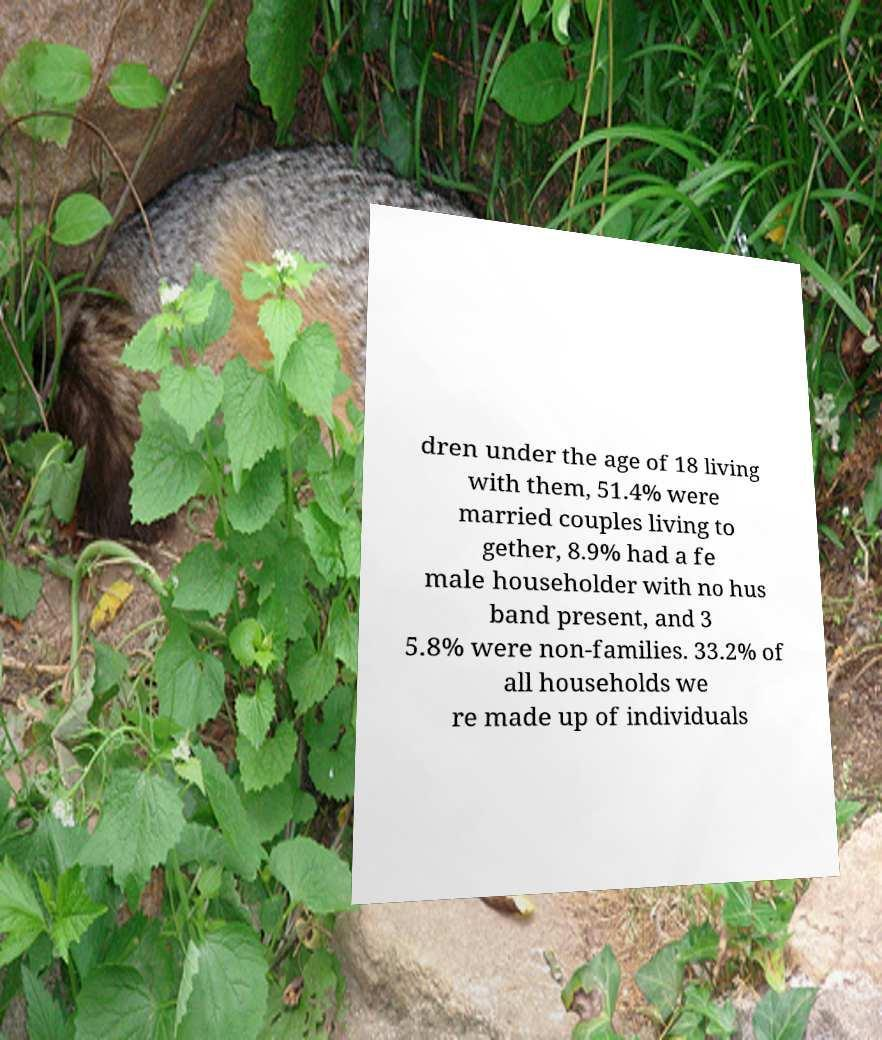Could you extract and type out the text from this image? dren under the age of 18 living with them, 51.4% were married couples living to gether, 8.9% had a fe male householder with no hus band present, and 3 5.8% were non-families. 33.2% of all households we re made up of individuals 